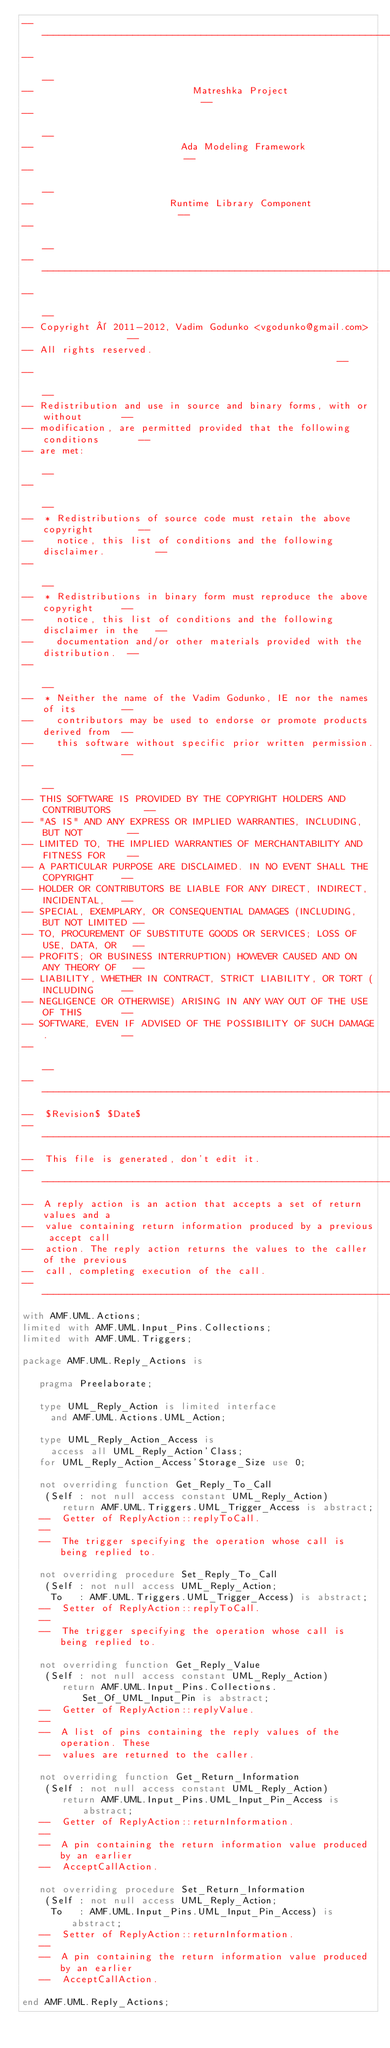Convert code to text. <code><loc_0><loc_0><loc_500><loc_500><_Ada_>------------------------------------------------------------------------------
--                                                                          --
--                            Matreshka Project                             --
--                                                                          --
--                          Ada Modeling Framework                          --
--                                                                          --
--                        Runtime Library Component                         --
--                                                                          --
------------------------------------------------------------------------------
--                                                                          --
-- Copyright © 2011-2012, Vadim Godunko <vgodunko@gmail.com>                --
-- All rights reserved.                                                     --
--                                                                          --
-- Redistribution and use in source and binary forms, with or without       --
-- modification, are permitted provided that the following conditions       --
-- are met:                                                                 --
--                                                                          --
--  * Redistributions of source code must retain the above copyright        --
--    notice, this list of conditions and the following disclaimer.         --
--                                                                          --
--  * Redistributions in binary form must reproduce the above copyright     --
--    notice, this list of conditions and the following disclaimer in the   --
--    documentation and/or other materials provided with the distribution.  --
--                                                                          --
--  * Neither the name of the Vadim Godunko, IE nor the names of its        --
--    contributors may be used to endorse or promote products derived from  --
--    this software without specific prior written permission.              --
--                                                                          --
-- THIS SOFTWARE IS PROVIDED BY THE COPYRIGHT HOLDERS AND CONTRIBUTORS      --
-- "AS IS" AND ANY EXPRESS OR IMPLIED WARRANTIES, INCLUDING, BUT NOT        --
-- LIMITED TO, THE IMPLIED WARRANTIES OF MERCHANTABILITY AND FITNESS FOR    --
-- A PARTICULAR PURPOSE ARE DISCLAIMED. IN NO EVENT SHALL THE COPYRIGHT     --
-- HOLDER OR CONTRIBUTORS BE LIABLE FOR ANY DIRECT, INDIRECT, INCIDENTAL,   --
-- SPECIAL, EXEMPLARY, OR CONSEQUENTIAL DAMAGES (INCLUDING, BUT NOT LIMITED --
-- TO, PROCUREMENT OF SUBSTITUTE GOODS OR SERVICES; LOSS OF USE, DATA, OR   --
-- PROFITS; OR BUSINESS INTERRUPTION) HOWEVER CAUSED AND ON ANY THEORY OF   --
-- LIABILITY, WHETHER IN CONTRACT, STRICT LIABILITY, OR TORT (INCLUDING     --
-- NEGLIGENCE OR OTHERWISE) ARISING IN ANY WAY OUT OF THE USE OF THIS       --
-- SOFTWARE, EVEN IF ADVISED OF THE POSSIBILITY OF SUCH DAMAGE.             --
--                                                                          --
------------------------------------------------------------------------------
--  $Revision$ $Date$
------------------------------------------------------------------------------
--  This file is generated, don't edit it.
------------------------------------------------------------------------------
--  A reply action is an action that accepts a set of return values and a 
--  value containing return information produced by a previous accept call 
--  action. The reply action returns the values to the caller of the previous 
--  call, completing execution of the call.
------------------------------------------------------------------------------
with AMF.UML.Actions;
limited with AMF.UML.Input_Pins.Collections;
limited with AMF.UML.Triggers;

package AMF.UML.Reply_Actions is

   pragma Preelaborate;

   type UML_Reply_Action is limited interface
     and AMF.UML.Actions.UML_Action;

   type UML_Reply_Action_Access is
     access all UML_Reply_Action'Class;
   for UML_Reply_Action_Access'Storage_Size use 0;

   not overriding function Get_Reply_To_Call
    (Self : not null access constant UML_Reply_Action)
       return AMF.UML.Triggers.UML_Trigger_Access is abstract;
   --  Getter of ReplyAction::replyToCall.
   --
   --  The trigger specifying the operation whose call is being replied to.

   not overriding procedure Set_Reply_To_Call
    (Self : not null access UML_Reply_Action;
     To   : AMF.UML.Triggers.UML_Trigger_Access) is abstract;
   --  Setter of ReplyAction::replyToCall.
   --
   --  The trigger specifying the operation whose call is being replied to.

   not overriding function Get_Reply_Value
    (Self : not null access constant UML_Reply_Action)
       return AMF.UML.Input_Pins.Collections.Set_Of_UML_Input_Pin is abstract;
   --  Getter of ReplyAction::replyValue.
   --
   --  A list of pins containing the reply values of the operation. These 
   --  values are returned to the caller.

   not overriding function Get_Return_Information
    (Self : not null access constant UML_Reply_Action)
       return AMF.UML.Input_Pins.UML_Input_Pin_Access is abstract;
   --  Getter of ReplyAction::returnInformation.
   --
   --  A pin containing the return information value produced by an earlier 
   --  AcceptCallAction.

   not overriding procedure Set_Return_Information
    (Self : not null access UML_Reply_Action;
     To   : AMF.UML.Input_Pins.UML_Input_Pin_Access) is abstract;
   --  Setter of ReplyAction::returnInformation.
   --
   --  A pin containing the return information value produced by an earlier 
   --  AcceptCallAction.

end AMF.UML.Reply_Actions;
</code> 